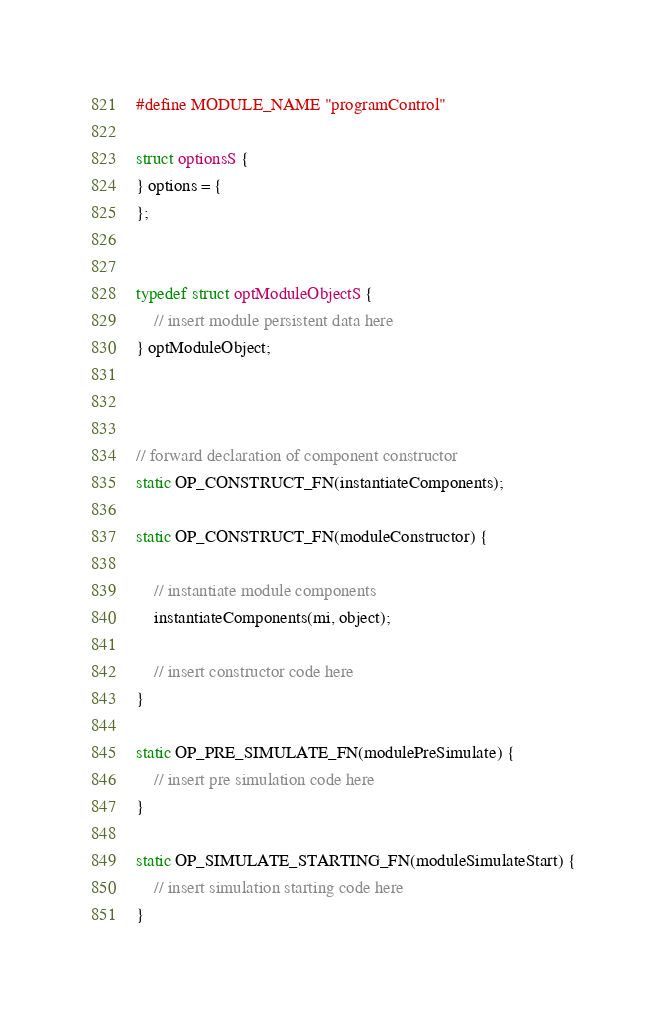<code> <loc_0><loc_0><loc_500><loc_500><_C_>

#define MODULE_NAME "programControl"

struct optionsS {
} options = {
};


typedef struct optModuleObjectS {
    // insert module persistent data here
} optModuleObject;



// forward declaration of component constructor
static OP_CONSTRUCT_FN(instantiateComponents);

static OP_CONSTRUCT_FN(moduleConstructor) {

    // instantiate module components
    instantiateComponents(mi, object);

    // insert constructor code here
}

static OP_PRE_SIMULATE_FN(modulePreSimulate) {
    // insert pre simulation code here
}

static OP_SIMULATE_STARTING_FN(moduleSimulateStart) {
    // insert simulation starting code here
}
</code> 